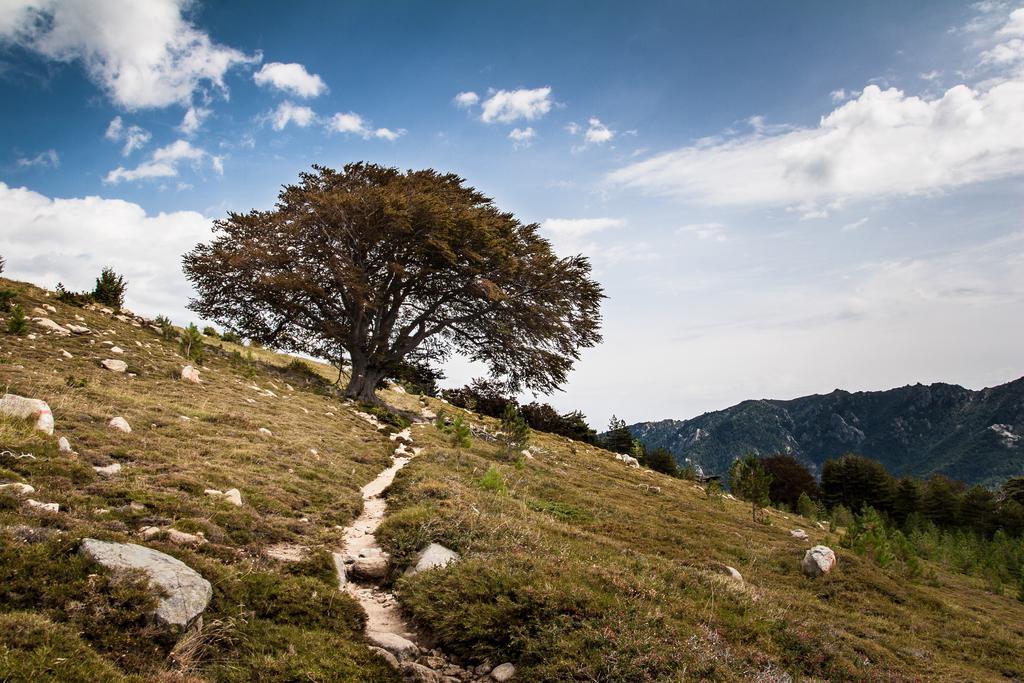Describe this image in one or two sentences. In this image there are trees. In the background there are hills and sky. At the bottom there is grass. 